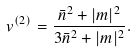<formula> <loc_0><loc_0><loc_500><loc_500>v ^ { ( 2 ) } = \frac { \bar { n } ^ { 2 } + | m | ^ { 2 } } { 3 \bar { n } ^ { 2 } + | m | ^ { 2 } } .</formula> 